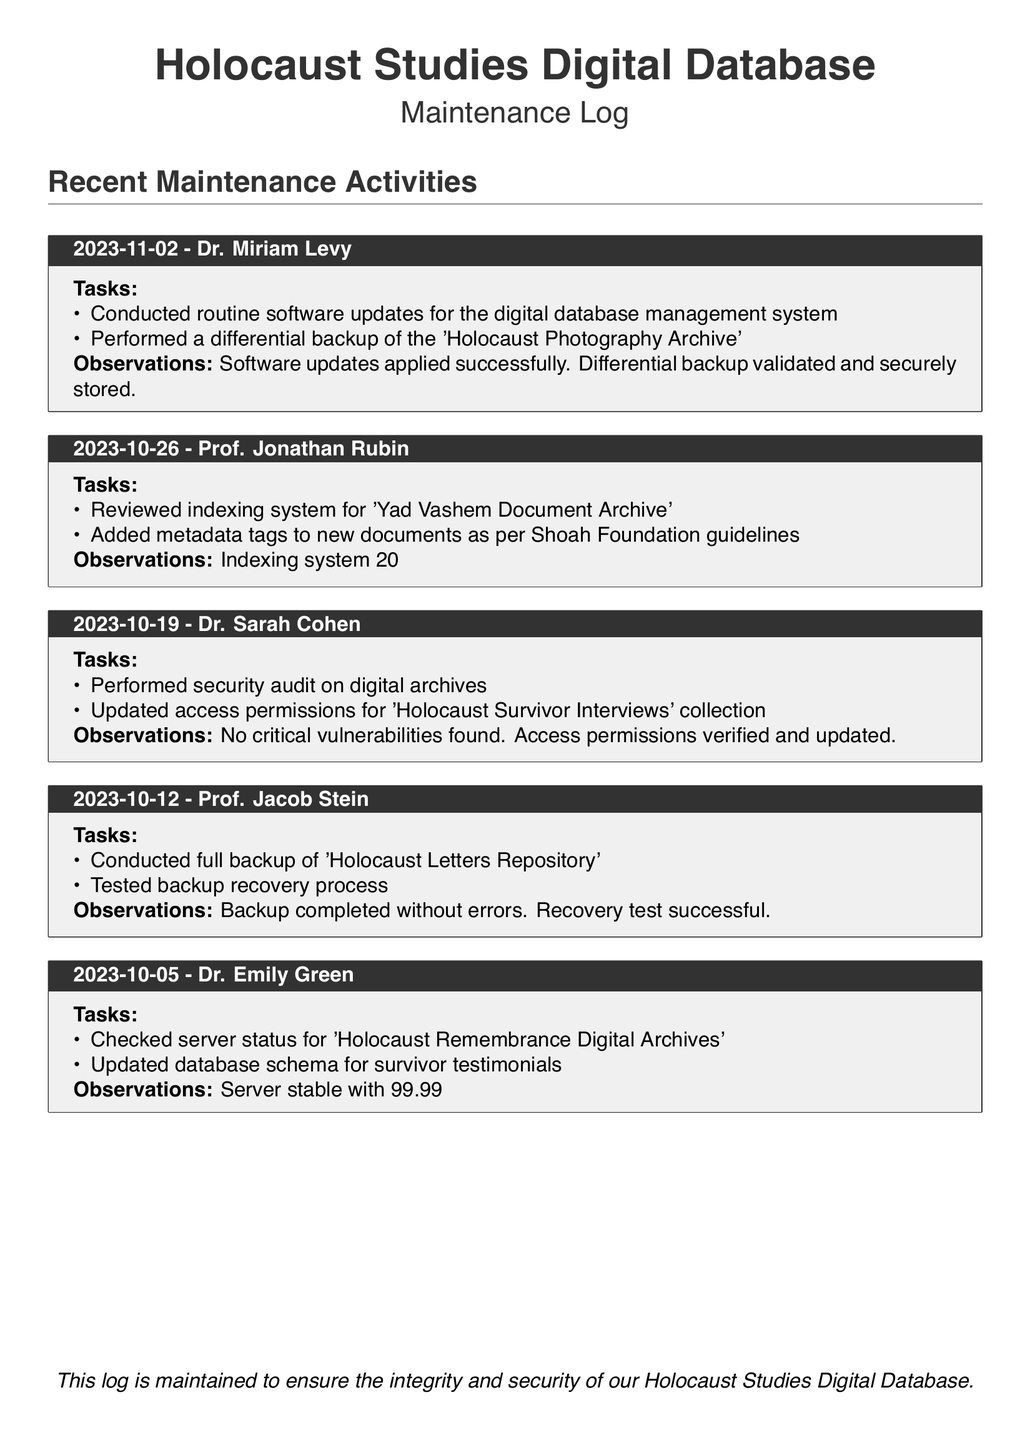What date was the last maintenance activity recorded? The last maintenance activity recorded in the log is from November 2, 2023.
Answer: November 2, 2023 Who performed the security audit on digital archives? The security audit was performed by Dr. Sarah Cohen on October 19, 2023.
Answer: Dr. Sarah Cohen What percentage faster is the indexing system after review? The indexing system is reported to be 20% faster after review on October 26, 2023.
Answer: 20% What was tested in the full backup conducted on October 12, 2023? A recovery test was performed to ensure the backup was valid after the full backup of the 'Holocaust Letters Repository'.
Answer: Recovery test What specific collection had its access permissions updated recently? The access permissions for the 'Holocaust Survivor Interviews' collection were updated on October 19, 2023.
Answer: Holocaust Survivor Interviews What was the uptime percentage of the server for the 'Holocaust Remembrance Digital Archives'? The server for the 'Holocaust Remembrance Digital Archives' maintained a status of 99.99% uptime as checked on October 5, 2023.
Answer: 99.99% What is the main purpose of maintaining this log? The log is maintained to ensure the integrity and security of the Holocaust Studies Digital Database.
Answer: Integrity and security How many routine software updates were conducted on November 2, 2023? Routine software updates were conducted, but a specific number is not provided. The log states "routine" indicating regularity rather than quantity.
Answer: Routine Who conducted the full backup on October 12, 2023? The full backup was conducted by Prof. Jacob Stein on October 12, 2023.
Answer: Prof. Jacob Stein 